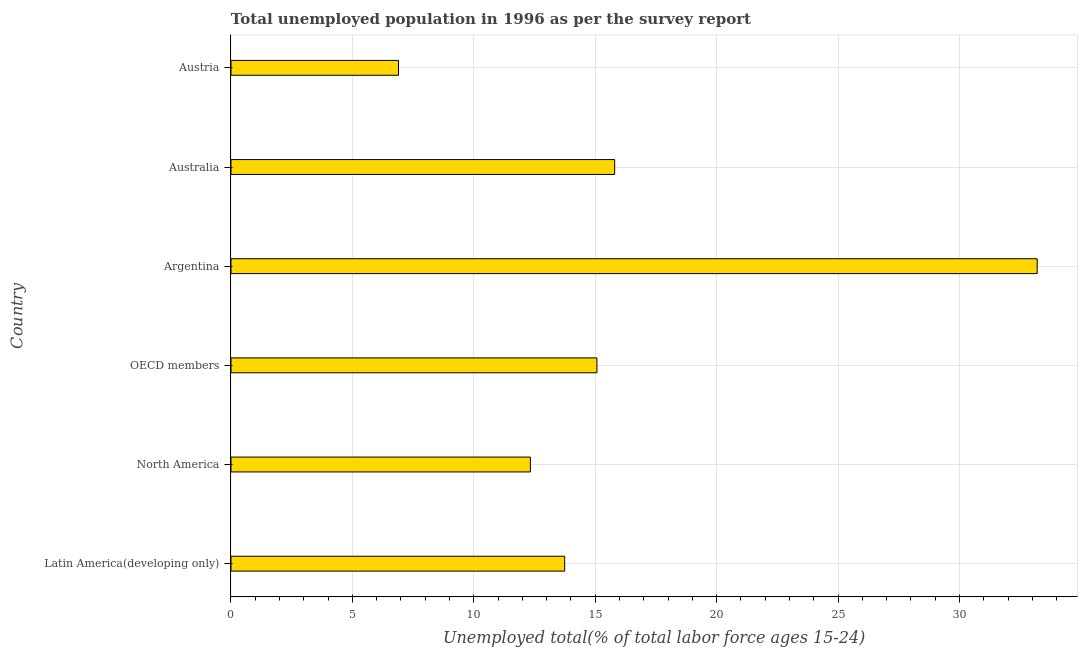What is the title of the graph?
Your response must be concise. Total unemployed population in 1996 as per the survey report. What is the label or title of the X-axis?
Make the answer very short. Unemployed total(% of total labor force ages 15-24). What is the label or title of the Y-axis?
Offer a very short reply. Country. What is the unemployed youth in Latin America(developing only)?
Your answer should be compact. 13.74. Across all countries, what is the maximum unemployed youth?
Offer a terse response. 33.2. Across all countries, what is the minimum unemployed youth?
Make the answer very short. 6.9. In which country was the unemployed youth maximum?
Give a very brief answer. Argentina. What is the sum of the unemployed youth?
Ensure brevity in your answer.  97.04. What is the difference between the unemployed youth in Australia and OECD members?
Your answer should be very brief. 0.73. What is the average unemployed youth per country?
Give a very brief answer. 16.17. What is the median unemployed youth?
Make the answer very short. 14.41. In how many countries, is the unemployed youth greater than 25 %?
Your answer should be compact. 1. What is the ratio of the unemployed youth in Australia to that in North America?
Ensure brevity in your answer.  1.28. What is the difference between the highest and the lowest unemployed youth?
Offer a terse response. 26.3. In how many countries, is the unemployed youth greater than the average unemployed youth taken over all countries?
Your answer should be very brief. 1. What is the difference between two consecutive major ticks on the X-axis?
Offer a terse response. 5. Are the values on the major ticks of X-axis written in scientific E-notation?
Give a very brief answer. No. What is the Unemployed total(% of total labor force ages 15-24) in Latin America(developing only)?
Provide a succinct answer. 13.74. What is the Unemployed total(% of total labor force ages 15-24) of North America?
Ensure brevity in your answer.  12.33. What is the Unemployed total(% of total labor force ages 15-24) in OECD members?
Provide a short and direct response. 15.07. What is the Unemployed total(% of total labor force ages 15-24) in Argentina?
Provide a succinct answer. 33.2. What is the Unemployed total(% of total labor force ages 15-24) of Australia?
Your response must be concise. 15.8. What is the Unemployed total(% of total labor force ages 15-24) in Austria?
Your answer should be compact. 6.9. What is the difference between the Unemployed total(% of total labor force ages 15-24) in Latin America(developing only) and North America?
Offer a terse response. 1.41. What is the difference between the Unemployed total(% of total labor force ages 15-24) in Latin America(developing only) and OECD members?
Keep it short and to the point. -1.33. What is the difference between the Unemployed total(% of total labor force ages 15-24) in Latin America(developing only) and Argentina?
Provide a succinct answer. -19.46. What is the difference between the Unemployed total(% of total labor force ages 15-24) in Latin America(developing only) and Australia?
Your answer should be very brief. -2.06. What is the difference between the Unemployed total(% of total labor force ages 15-24) in Latin America(developing only) and Austria?
Provide a short and direct response. 6.84. What is the difference between the Unemployed total(% of total labor force ages 15-24) in North America and OECD members?
Make the answer very short. -2.74. What is the difference between the Unemployed total(% of total labor force ages 15-24) in North America and Argentina?
Provide a succinct answer. -20.87. What is the difference between the Unemployed total(% of total labor force ages 15-24) in North America and Australia?
Your answer should be very brief. -3.47. What is the difference between the Unemployed total(% of total labor force ages 15-24) in North America and Austria?
Your response must be concise. 5.43. What is the difference between the Unemployed total(% of total labor force ages 15-24) in OECD members and Argentina?
Ensure brevity in your answer.  -18.13. What is the difference between the Unemployed total(% of total labor force ages 15-24) in OECD members and Australia?
Ensure brevity in your answer.  -0.73. What is the difference between the Unemployed total(% of total labor force ages 15-24) in OECD members and Austria?
Give a very brief answer. 8.17. What is the difference between the Unemployed total(% of total labor force ages 15-24) in Argentina and Australia?
Your response must be concise. 17.4. What is the difference between the Unemployed total(% of total labor force ages 15-24) in Argentina and Austria?
Your answer should be compact. 26.3. What is the difference between the Unemployed total(% of total labor force ages 15-24) in Australia and Austria?
Offer a very short reply. 8.9. What is the ratio of the Unemployed total(% of total labor force ages 15-24) in Latin America(developing only) to that in North America?
Give a very brief answer. 1.11. What is the ratio of the Unemployed total(% of total labor force ages 15-24) in Latin America(developing only) to that in OECD members?
Your response must be concise. 0.91. What is the ratio of the Unemployed total(% of total labor force ages 15-24) in Latin America(developing only) to that in Argentina?
Your answer should be very brief. 0.41. What is the ratio of the Unemployed total(% of total labor force ages 15-24) in Latin America(developing only) to that in Australia?
Provide a short and direct response. 0.87. What is the ratio of the Unemployed total(% of total labor force ages 15-24) in Latin America(developing only) to that in Austria?
Your response must be concise. 1.99. What is the ratio of the Unemployed total(% of total labor force ages 15-24) in North America to that in OECD members?
Ensure brevity in your answer.  0.82. What is the ratio of the Unemployed total(% of total labor force ages 15-24) in North America to that in Argentina?
Your answer should be very brief. 0.37. What is the ratio of the Unemployed total(% of total labor force ages 15-24) in North America to that in Australia?
Your response must be concise. 0.78. What is the ratio of the Unemployed total(% of total labor force ages 15-24) in North America to that in Austria?
Your answer should be compact. 1.79. What is the ratio of the Unemployed total(% of total labor force ages 15-24) in OECD members to that in Argentina?
Offer a very short reply. 0.45. What is the ratio of the Unemployed total(% of total labor force ages 15-24) in OECD members to that in Australia?
Ensure brevity in your answer.  0.95. What is the ratio of the Unemployed total(% of total labor force ages 15-24) in OECD members to that in Austria?
Provide a short and direct response. 2.18. What is the ratio of the Unemployed total(% of total labor force ages 15-24) in Argentina to that in Australia?
Provide a succinct answer. 2.1. What is the ratio of the Unemployed total(% of total labor force ages 15-24) in Argentina to that in Austria?
Your answer should be compact. 4.81. What is the ratio of the Unemployed total(% of total labor force ages 15-24) in Australia to that in Austria?
Your answer should be very brief. 2.29. 